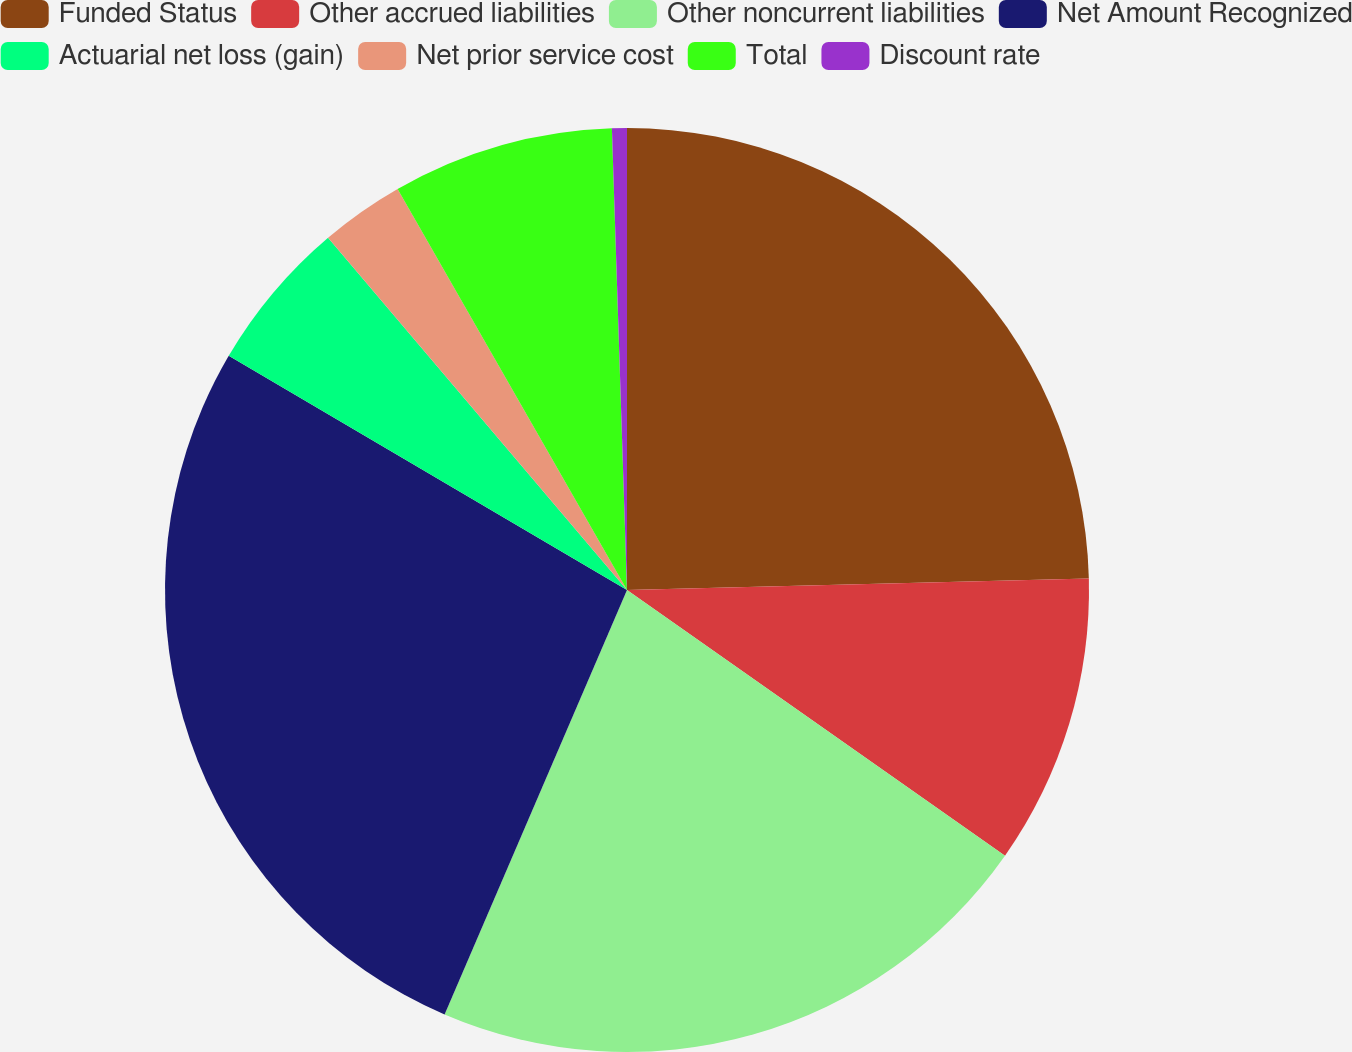Convert chart. <chart><loc_0><loc_0><loc_500><loc_500><pie_chart><fcel>Funded Status<fcel>Other accrued liabilities<fcel>Other noncurrent liabilities<fcel>Net Amount Recognized<fcel>Actuarial net loss (gain)<fcel>Net prior service cost<fcel>Total<fcel>Discount rate<nl><fcel>24.6%<fcel>10.15%<fcel>21.71%<fcel>27.0%<fcel>5.34%<fcel>2.93%<fcel>7.75%<fcel>0.52%<nl></chart> 